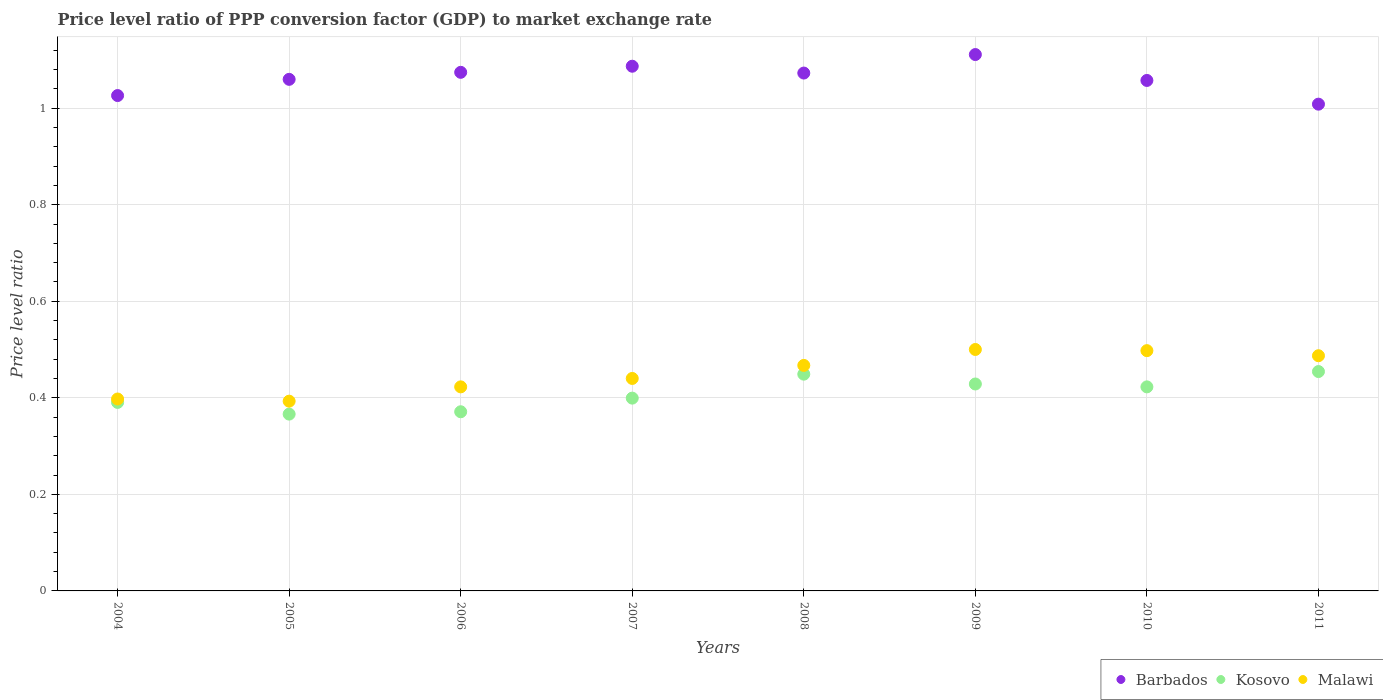How many different coloured dotlines are there?
Ensure brevity in your answer.  3. What is the price level ratio in Malawi in 2009?
Your answer should be very brief. 0.5. Across all years, what is the maximum price level ratio in Barbados?
Your response must be concise. 1.11. Across all years, what is the minimum price level ratio in Malawi?
Offer a very short reply. 0.39. In which year was the price level ratio in Malawi maximum?
Provide a succinct answer. 2009. In which year was the price level ratio in Barbados minimum?
Provide a short and direct response. 2011. What is the total price level ratio in Kosovo in the graph?
Offer a very short reply. 3.28. What is the difference between the price level ratio in Barbados in 2005 and that in 2011?
Make the answer very short. 0.05. What is the difference between the price level ratio in Malawi in 2008 and the price level ratio in Kosovo in 2009?
Your response must be concise. 0.04. What is the average price level ratio in Barbados per year?
Offer a very short reply. 1.06. In the year 2011, what is the difference between the price level ratio in Malawi and price level ratio in Kosovo?
Keep it short and to the point. 0.03. What is the ratio of the price level ratio in Kosovo in 2007 to that in 2011?
Make the answer very short. 0.88. What is the difference between the highest and the second highest price level ratio in Barbados?
Provide a succinct answer. 0.02. What is the difference between the highest and the lowest price level ratio in Malawi?
Your response must be concise. 0.11. Is the sum of the price level ratio in Malawi in 2005 and 2009 greater than the maximum price level ratio in Kosovo across all years?
Your response must be concise. Yes. Does the price level ratio in Barbados monotonically increase over the years?
Provide a succinct answer. No. Is the price level ratio in Malawi strictly greater than the price level ratio in Barbados over the years?
Make the answer very short. No. Is the price level ratio in Kosovo strictly less than the price level ratio in Barbados over the years?
Provide a short and direct response. Yes. How many dotlines are there?
Offer a very short reply. 3. How many years are there in the graph?
Provide a short and direct response. 8. Does the graph contain any zero values?
Keep it short and to the point. No. Does the graph contain grids?
Provide a short and direct response. Yes. Where does the legend appear in the graph?
Keep it short and to the point. Bottom right. How are the legend labels stacked?
Ensure brevity in your answer.  Horizontal. What is the title of the graph?
Provide a short and direct response. Price level ratio of PPP conversion factor (GDP) to market exchange rate. Does "Macedonia" appear as one of the legend labels in the graph?
Make the answer very short. No. What is the label or title of the Y-axis?
Provide a short and direct response. Price level ratio. What is the Price level ratio in Barbados in 2004?
Provide a succinct answer. 1.03. What is the Price level ratio of Kosovo in 2004?
Give a very brief answer. 0.39. What is the Price level ratio in Malawi in 2004?
Keep it short and to the point. 0.4. What is the Price level ratio of Barbados in 2005?
Offer a very short reply. 1.06. What is the Price level ratio of Kosovo in 2005?
Provide a succinct answer. 0.37. What is the Price level ratio of Malawi in 2005?
Your answer should be very brief. 0.39. What is the Price level ratio in Barbados in 2006?
Offer a terse response. 1.07. What is the Price level ratio in Kosovo in 2006?
Offer a very short reply. 0.37. What is the Price level ratio of Malawi in 2006?
Offer a very short reply. 0.42. What is the Price level ratio in Barbados in 2007?
Offer a very short reply. 1.09. What is the Price level ratio in Kosovo in 2007?
Make the answer very short. 0.4. What is the Price level ratio of Malawi in 2007?
Your response must be concise. 0.44. What is the Price level ratio in Barbados in 2008?
Offer a terse response. 1.07. What is the Price level ratio of Kosovo in 2008?
Offer a terse response. 0.45. What is the Price level ratio in Malawi in 2008?
Offer a very short reply. 0.47. What is the Price level ratio of Barbados in 2009?
Your answer should be very brief. 1.11. What is the Price level ratio in Kosovo in 2009?
Offer a very short reply. 0.43. What is the Price level ratio of Malawi in 2009?
Your response must be concise. 0.5. What is the Price level ratio of Barbados in 2010?
Provide a short and direct response. 1.06. What is the Price level ratio of Kosovo in 2010?
Your response must be concise. 0.42. What is the Price level ratio of Malawi in 2010?
Provide a short and direct response. 0.5. What is the Price level ratio of Barbados in 2011?
Provide a short and direct response. 1.01. What is the Price level ratio of Kosovo in 2011?
Ensure brevity in your answer.  0.45. What is the Price level ratio in Malawi in 2011?
Provide a short and direct response. 0.49. Across all years, what is the maximum Price level ratio in Barbados?
Provide a succinct answer. 1.11. Across all years, what is the maximum Price level ratio in Kosovo?
Ensure brevity in your answer.  0.45. Across all years, what is the maximum Price level ratio of Malawi?
Provide a succinct answer. 0.5. Across all years, what is the minimum Price level ratio of Barbados?
Offer a terse response. 1.01. Across all years, what is the minimum Price level ratio in Kosovo?
Offer a very short reply. 0.37. Across all years, what is the minimum Price level ratio in Malawi?
Make the answer very short. 0.39. What is the total Price level ratio in Barbados in the graph?
Make the answer very short. 8.5. What is the total Price level ratio in Kosovo in the graph?
Provide a short and direct response. 3.28. What is the total Price level ratio of Malawi in the graph?
Provide a short and direct response. 3.61. What is the difference between the Price level ratio of Barbados in 2004 and that in 2005?
Your answer should be compact. -0.03. What is the difference between the Price level ratio in Kosovo in 2004 and that in 2005?
Provide a short and direct response. 0.02. What is the difference between the Price level ratio of Malawi in 2004 and that in 2005?
Keep it short and to the point. 0. What is the difference between the Price level ratio of Barbados in 2004 and that in 2006?
Offer a very short reply. -0.05. What is the difference between the Price level ratio in Kosovo in 2004 and that in 2006?
Your answer should be very brief. 0.02. What is the difference between the Price level ratio of Malawi in 2004 and that in 2006?
Provide a short and direct response. -0.03. What is the difference between the Price level ratio of Barbados in 2004 and that in 2007?
Your answer should be very brief. -0.06. What is the difference between the Price level ratio of Kosovo in 2004 and that in 2007?
Provide a short and direct response. -0.01. What is the difference between the Price level ratio of Malawi in 2004 and that in 2007?
Offer a terse response. -0.04. What is the difference between the Price level ratio of Barbados in 2004 and that in 2008?
Ensure brevity in your answer.  -0.05. What is the difference between the Price level ratio in Kosovo in 2004 and that in 2008?
Your response must be concise. -0.06. What is the difference between the Price level ratio in Malawi in 2004 and that in 2008?
Keep it short and to the point. -0.07. What is the difference between the Price level ratio in Barbados in 2004 and that in 2009?
Your response must be concise. -0.08. What is the difference between the Price level ratio in Kosovo in 2004 and that in 2009?
Keep it short and to the point. -0.04. What is the difference between the Price level ratio in Malawi in 2004 and that in 2009?
Make the answer very short. -0.1. What is the difference between the Price level ratio of Barbados in 2004 and that in 2010?
Your answer should be very brief. -0.03. What is the difference between the Price level ratio in Kosovo in 2004 and that in 2010?
Your response must be concise. -0.03. What is the difference between the Price level ratio in Malawi in 2004 and that in 2010?
Provide a short and direct response. -0.1. What is the difference between the Price level ratio in Barbados in 2004 and that in 2011?
Your response must be concise. 0.02. What is the difference between the Price level ratio of Kosovo in 2004 and that in 2011?
Keep it short and to the point. -0.06. What is the difference between the Price level ratio in Malawi in 2004 and that in 2011?
Provide a short and direct response. -0.09. What is the difference between the Price level ratio of Barbados in 2005 and that in 2006?
Provide a short and direct response. -0.01. What is the difference between the Price level ratio in Kosovo in 2005 and that in 2006?
Make the answer very short. -0. What is the difference between the Price level ratio in Malawi in 2005 and that in 2006?
Offer a terse response. -0.03. What is the difference between the Price level ratio in Barbados in 2005 and that in 2007?
Give a very brief answer. -0.03. What is the difference between the Price level ratio in Kosovo in 2005 and that in 2007?
Make the answer very short. -0.03. What is the difference between the Price level ratio of Malawi in 2005 and that in 2007?
Make the answer very short. -0.05. What is the difference between the Price level ratio in Barbados in 2005 and that in 2008?
Your answer should be compact. -0.01. What is the difference between the Price level ratio in Kosovo in 2005 and that in 2008?
Give a very brief answer. -0.08. What is the difference between the Price level ratio of Malawi in 2005 and that in 2008?
Offer a terse response. -0.07. What is the difference between the Price level ratio of Barbados in 2005 and that in 2009?
Make the answer very short. -0.05. What is the difference between the Price level ratio of Kosovo in 2005 and that in 2009?
Give a very brief answer. -0.06. What is the difference between the Price level ratio of Malawi in 2005 and that in 2009?
Provide a succinct answer. -0.11. What is the difference between the Price level ratio in Barbados in 2005 and that in 2010?
Offer a terse response. 0. What is the difference between the Price level ratio in Kosovo in 2005 and that in 2010?
Offer a terse response. -0.06. What is the difference between the Price level ratio of Malawi in 2005 and that in 2010?
Your answer should be very brief. -0.1. What is the difference between the Price level ratio of Barbados in 2005 and that in 2011?
Provide a short and direct response. 0.05. What is the difference between the Price level ratio of Kosovo in 2005 and that in 2011?
Your answer should be very brief. -0.09. What is the difference between the Price level ratio in Malawi in 2005 and that in 2011?
Your answer should be very brief. -0.09. What is the difference between the Price level ratio of Barbados in 2006 and that in 2007?
Your response must be concise. -0.01. What is the difference between the Price level ratio in Kosovo in 2006 and that in 2007?
Make the answer very short. -0.03. What is the difference between the Price level ratio of Malawi in 2006 and that in 2007?
Make the answer very short. -0.02. What is the difference between the Price level ratio in Barbados in 2006 and that in 2008?
Provide a succinct answer. 0. What is the difference between the Price level ratio of Kosovo in 2006 and that in 2008?
Make the answer very short. -0.08. What is the difference between the Price level ratio of Malawi in 2006 and that in 2008?
Ensure brevity in your answer.  -0.04. What is the difference between the Price level ratio in Barbados in 2006 and that in 2009?
Your answer should be very brief. -0.04. What is the difference between the Price level ratio of Kosovo in 2006 and that in 2009?
Offer a terse response. -0.06. What is the difference between the Price level ratio of Malawi in 2006 and that in 2009?
Your answer should be compact. -0.08. What is the difference between the Price level ratio in Barbados in 2006 and that in 2010?
Offer a very short reply. 0.02. What is the difference between the Price level ratio in Kosovo in 2006 and that in 2010?
Your answer should be compact. -0.05. What is the difference between the Price level ratio in Malawi in 2006 and that in 2010?
Provide a short and direct response. -0.07. What is the difference between the Price level ratio of Barbados in 2006 and that in 2011?
Offer a very short reply. 0.07. What is the difference between the Price level ratio of Kosovo in 2006 and that in 2011?
Ensure brevity in your answer.  -0.08. What is the difference between the Price level ratio of Malawi in 2006 and that in 2011?
Offer a terse response. -0.06. What is the difference between the Price level ratio in Barbados in 2007 and that in 2008?
Give a very brief answer. 0.01. What is the difference between the Price level ratio of Kosovo in 2007 and that in 2008?
Make the answer very short. -0.05. What is the difference between the Price level ratio in Malawi in 2007 and that in 2008?
Ensure brevity in your answer.  -0.03. What is the difference between the Price level ratio of Barbados in 2007 and that in 2009?
Ensure brevity in your answer.  -0.02. What is the difference between the Price level ratio in Kosovo in 2007 and that in 2009?
Your response must be concise. -0.03. What is the difference between the Price level ratio in Malawi in 2007 and that in 2009?
Offer a terse response. -0.06. What is the difference between the Price level ratio of Barbados in 2007 and that in 2010?
Offer a terse response. 0.03. What is the difference between the Price level ratio of Kosovo in 2007 and that in 2010?
Your response must be concise. -0.02. What is the difference between the Price level ratio of Malawi in 2007 and that in 2010?
Provide a succinct answer. -0.06. What is the difference between the Price level ratio of Barbados in 2007 and that in 2011?
Your answer should be compact. 0.08. What is the difference between the Price level ratio of Kosovo in 2007 and that in 2011?
Ensure brevity in your answer.  -0.06. What is the difference between the Price level ratio of Malawi in 2007 and that in 2011?
Your answer should be compact. -0.05. What is the difference between the Price level ratio in Barbados in 2008 and that in 2009?
Offer a terse response. -0.04. What is the difference between the Price level ratio in Kosovo in 2008 and that in 2009?
Keep it short and to the point. 0.02. What is the difference between the Price level ratio of Malawi in 2008 and that in 2009?
Provide a short and direct response. -0.03. What is the difference between the Price level ratio of Barbados in 2008 and that in 2010?
Give a very brief answer. 0.02. What is the difference between the Price level ratio in Kosovo in 2008 and that in 2010?
Your answer should be very brief. 0.03. What is the difference between the Price level ratio in Malawi in 2008 and that in 2010?
Give a very brief answer. -0.03. What is the difference between the Price level ratio of Barbados in 2008 and that in 2011?
Make the answer very short. 0.06. What is the difference between the Price level ratio of Kosovo in 2008 and that in 2011?
Make the answer very short. -0.01. What is the difference between the Price level ratio of Malawi in 2008 and that in 2011?
Your response must be concise. -0.02. What is the difference between the Price level ratio in Barbados in 2009 and that in 2010?
Offer a very short reply. 0.05. What is the difference between the Price level ratio of Kosovo in 2009 and that in 2010?
Ensure brevity in your answer.  0.01. What is the difference between the Price level ratio of Malawi in 2009 and that in 2010?
Give a very brief answer. 0. What is the difference between the Price level ratio of Barbados in 2009 and that in 2011?
Make the answer very short. 0.1. What is the difference between the Price level ratio of Kosovo in 2009 and that in 2011?
Provide a succinct answer. -0.03. What is the difference between the Price level ratio of Malawi in 2009 and that in 2011?
Give a very brief answer. 0.01. What is the difference between the Price level ratio of Barbados in 2010 and that in 2011?
Offer a terse response. 0.05. What is the difference between the Price level ratio in Kosovo in 2010 and that in 2011?
Your answer should be compact. -0.03. What is the difference between the Price level ratio of Malawi in 2010 and that in 2011?
Offer a very short reply. 0.01. What is the difference between the Price level ratio of Barbados in 2004 and the Price level ratio of Kosovo in 2005?
Provide a short and direct response. 0.66. What is the difference between the Price level ratio in Barbados in 2004 and the Price level ratio in Malawi in 2005?
Provide a succinct answer. 0.63. What is the difference between the Price level ratio of Kosovo in 2004 and the Price level ratio of Malawi in 2005?
Make the answer very short. -0. What is the difference between the Price level ratio in Barbados in 2004 and the Price level ratio in Kosovo in 2006?
Make the answer very short. 0.66. What is the difference between the Price level ratio in Barbados in 2004 and the Price level ratio in Malawi in 2006?
Your answer should be compact. 0.6. What is the difference between the Price level ratio of Kosovo in 2004 and the Price level ratio of Malawi in 2006?
Offer a very short reply. -0.03. What is the difference between the Price level ratio in Barbados in 2004 and the Price level ratio in Kosovo in 2007?
Offer a terse response. 0.63. What is the difference between the Price level ratio of Barbados in 2004 and the Price level ratio of Malawi in 2007?
Your response must be concise. 0.59. What is the difference between the Price level ratio of Kosovo in 2004 and the Price level ratio of Malawi in 2007?
Provide a succinct answer. -0.05. What is the difference between the Price level ratio of Barbados in 2004 and the Price level ratio of Kosovo in 2008?
Your response must be concise. 0.58. What is the difference between the Price level ratio of Barbados in 2004 and the Price level ratio of Malawi in 2008?
Keep it short and to the point. 0.56. What is the difference between the Price level ratio in Kosovo in 2004 and the Price level ratio in Malawi in 2008?
Provide a short and direct response. -0.08. What is the difference between the Price level ratio of Barbados in 2004 and the Price level ratio of Kosovo in 2009?
Provide a short and direct response. 0.6. What is the difference between the Price level ratio of Barbados in 2004 and the Price level ratio of Malawi in 2009?
Provide a succinct answer. 0.53. What is the difference between the Price level ratio of Kosovo in 2004 and the Price level ratio of Malawi in 2009?
Make the answer very short. -0.11. What is the difference between the Price level ratio of Barbados in 2004 and the Price level ratio of Kosovo in 2010?
Make the answer very short. 0.6. What is the difference between the Price level ratio of Barbados in 2004 and the Price level ratio of Malawi in 2010?
Give a very brief answer. 0.53. What is the difference between the Price level ratio in Kosovo in 2004 and the Price level ratio in Malawi in 2010?
Keep it short and to the point. -0.11. What is the difference between the Price level ratio of Barbados in 2004 and the Price level ratio of Kosovo in 2011?
Make the answer very short. 0.57. What is the difference between the Price level ratio in Barbados in 2004 and the Price level ratio in Malawi in 2011?
Your answer should be very brief. 0.54. What is the difference between the Price level ratio of Kosovo in 2004 and the Price level ratio of Malawi in 2011?
Keep it short and to the point. -0.1. What is the difference between the Price level ratio in Barbados in 2005 and the Price level ratio in Kosovo in 2006?
Ensure brevity in your answer.  0.69. What is the difference between the Price level ratio in Barbados in 2005 and the Price level ratio in Malawi in 2006?
Keep it short and to the point. 0.64. What is the difference between the Price level ratio in Kosovo in 2005 and the Price level ratio in Malawi in 2006?
Your response must be concise. -0.06. What is the difference between the Price level ratio of Barbados in 2005 and the Price level ratio of Kosovo in 2007?
Offer a terse response. 0.66. What is the difference between the Price level ratio in Barbados in 2005 and the Price level ratio in Malawi in 2007?
Make the answer very short. 0.62. What is the difference between the Price level ratio in Kosovo in 2005 and the Price level ratio in Malawi in 2007?
Offer a terse response. -0.07. What is the difference between the Price level ratio in Barbados in 2005 and the Price level ratio in Kosovo in 2008?
Give a very brief answer. 0.61. What is the difference between the Price level ratio in Barbados in 2005 and the Price level ratio in Malawi in 2008?
Your answer should be very brief. 0.59. What is the difference between the Price level ratio of Kosovo in 2005 and the Price level ratio of Malawi in 2008?
Provide a succinct answer. -0.1. What is the difference between the Price level ratio in Barbados in 2005 and the Price level ratio in Kosovo in 2009?
Make the answer very short. 0.63. What is the difference between the Price level ratio of Barbados in 2005 and the Price level ratio of Malawi in 2009?
Offer a very short reply. 0.56. What is the difference between the Price level ratio of Kosovo in 2005 and the Price level ratio of Malawi in 2009?
Ensure brevity in your answer.  -0.13. What is the difference between the Price level ratio of Barbados in 2005 and the Price level ratio of Kosovo in 2010?
Provide a short and direct response. 0.64. What is the difference between the Price level ratio in Barbados in 2005 and the Price level ratio in Malawi in 2010?
Keep it short and to the point. 0.56. What is the difference between the Price level ratio of Kosovo in 2005 and the Price level ratio of Malawi in 2010?
Offer a terse response. -0.13. What is the difference between the Price level ratio of Barbados in 2005 and the Price level ratio of Kosovo in 2011?
Offer a very short reply. 0.61. What is the difference between the Price level ratio of Barbados in 2005 and the Price level ratio of Malawi in 2011?
Your response must be concise. 0.57. What is the difference between the Price level ratio of Kosovo in 2005 and the Price level ratio of Malawi in 2011?
Your response must be concise. -0.12. What is the difference between the Price level ratio in Barbados in 2006 and the Price level ratio in Kosovo in 2007?
Ensure brevity in your answer.  0.67. What is the difference between the Price level ratio of Barbados in 2006 and the Price level ratio of Malawi in 2007?
Provide a short and direct response. 0.63. What is the difference between the Price level ratio in Kosovo in 2006 and the Price level ratio in Malawi in 2007?
Offer a terse response. -0.07. What is the difference between the Price level ratio of Barbados in 2006 and the Price level ratio of Kosovo in 2008?
Offer a terse response. 0.63. What is the difference between the Price level ratio of Barbados in 2006 and the Price level ratio of Malawi in 2008?
Ensure brevity in your answer.  0.61. What is the difference between the Price level ratio of Kosovo in 2006 and the Price level ratio of Malawi in 2008?
Give a very brief answer. -0.1. What is the difference between the Price level ratio in Barbados in 2006 and the Price level ratio in Kosovo in 2009?
Provide a short and direct response. 0.65. What is the difference between the Price level ratio in Barbados in 2006 and the Price level ratio in Malawi in 2009?
Your answer should be compact. 0.57. What is the difference between the Price level ratio of Kosovo in 2006 and the Price level ratio of Malawi in 2009?
Keep it short and to the point. -0.13. What is the difference between the Price level ratio in Barbados in 2006 and the Price level ratio in Kosovo in 2010?
Ensure brevity in your answer.  0.65. What is the difference between the Price level ratio in Barbados in 2006 and the Price level ratio in Malawi in 2010?
Your response must be concise. 0.58. What is the difference between the Price level ratio of Kosovo in 2006 and the Price level ratio of Malawi in 2010?
Make the answer very short. -0.13. What is the difference between the Price level ratio of Barbados in 2006 and the Price level ratio of Kosovo in 2011?
Offer a terse response. 0.62. What is the difference between the Price level ratio in Barbados in 2006 and the Price level ratio in Malawi in 2011?
Offer a terse response. 0.59. What is the difference between the Price level ratio in Kosovo in 2006 and the Price level ratio in Malawi in 2011?
Give a very brief answer. -0.12. What is the difference between the Price level ratio of Barbados in 2007 and the Price level ratio of Kosovo in 2008?
Your answer should be very brief. 0.64. What is the difference between the Price level ratio of Barbados in 2007 and the Price level ratio of Malawi in 2008?
Ensure brevity in your answer.  0.62. What is the difference between the Price level ratio in Kosovo in 2007 and the Price level ratio in Malawi in 2008?
Offer a very short reply. -0.07. What is the difference between the Price level ratio in Barbados in 2007 and the Price level ratio in Kosovo in 2009?
Give a very brief answer. 0.66. What is the difference between the Price level ratio in Barbados in 2007 and the Price level ratio in Malawi in 2009?
Ensure brevity in your answer.  0.59. What is the difference between the Price level ratio of Kosovo in 2007 and the Price level ratio of Malawi in 2009?
Your answer should be very brief. -0.1. What is the difference between the Price level ratio of Barbados in 2007 and the Price level ratio of Kosovo in 2010?
Your response must be concise. 0.66. What is the difference between the Price level ratio of Barbados in 2007 and the Price level ratio of Malawi in 2010?
Provide a short and direct response. 0.59. What is the difference between the Price level ratio of Kosovo in 2007 and the Price level ratio of Malawi in 2010?
Offer a very short reply. -0.1. What is the difference between the Price level ratio of Barbados in 2007 and the Price level ratio of Kosovo in 2011?
Make the answer very short. 0.63. What is the difference between the Price level ratio in Barbados in 2007 and the Price level ratio in Malawi in 2011?
Provide a short and direct response. 0.6. What is the difference between the Price level ratio in Kosovo in 2007 and the Price level ratio in Malawi in 2011?
Ensure brevity in your answer.  -0.09. What is the difference between the Price level ratio in Barbados in 2008 and the Price level ratio in Kosovo in 2009?
Your answer should be compact. 0.64. What is the difference between the Price level ratio of Barbados in 2008 and the Price level ratio of Malawi in 2009?
Your answer should be compact. 0.57. What is the difference between the Price level ratio of Kosovo in 2008 and the Price level ratio of Malawi in 2009?
Your response must be concise. -0.05. What is the difference between the Price level ratio in Barbados in 2008 and the Price level ratio in Kosovo in 2010?
Your response must be concise. 0.65. What is the difference between the Price level ratio in Barbados in 2008 and the Price level ratio in Malawi in 2010?
Give a very brief answer. 0.58. What is the difference between the Price level ratio in Kosovo in 2008 and the Price level ratio in Malawi in 2010?
Offer a terse response. -0.05. What is the difference between the Price level ratio of Barbados in 2008 and the Price level ratio of Kosovo in 2011?
Ensure brevity in your answer.  0.62. What is the difference between the Price level ratio in Barbados in 2008 and the Price level ratio in Malawi in 2011?
Ensure brevity in your answer.  0.59. What is the difference between the Price level ratio in Kosovo in 2008 and the Price level ratio in Malawi in 2011?
Your answer should be very brief. -0.04. What is the difference between the Price level ratio in Barbados in 2009 and the Price level ratio in Kosovo in 2010?
Make the answer very short. 0.69. What is the difference between the Price level ratio in Barbados in 2009 and the Price level ratio in Malawi in 2010?
Your answer should be very brief. 0.61. What is the difference between the Price level ratio in Kosovo in 2009 and the Price level ratio in Malawi in 2010?
Offer a very short reply. -0.07. What is the difference between the Price level ratio in Barbados in 2009 and the Price level ratio in Kosovo in 2011?
Keep it short and to the point. 0.66. What is the difference between the Price level ratio of Barbados in 2009 and the Price level ratio of Malawi in 2011?
Make the answer very short. 0.62. What is the difference between the Price level ratio of Kosovo in 2009 and the Price level ratio of Malawi in 2011?
Your response must be concise. -0.06. What is the difference between the Price level ratio of Barbados in 2010 and the Price level ratio of Kosovo in 2011?
Ensure brevity in your answer.  0.6. What is the difference between the Price level ratio in Barbados in 2010 and the Price level ratio in Malawi in 2011?
Provide a succinct answer. 0.57. What is the difference between the Price level ratio of Kosovo in 2010 and the Price level ratio of Malawi in 2011?
Offer a very short reply. -0.06. What is the average Price level ratio in Barbados per year?
Your answer should be compact. 1.06. What is the average Price level ratio in Kosovo per year?
Your answer should be compact. 0.41. What is the average Price level ratio of Malawi per year?
Your answer should be very brief. 0.45. In the year 2004, what is the difference between the Price level ratio in Barbados and Price level ratio in Kosovo?
Provide a short and direct response. 0.64. In the year 2004, what is the difference between the Price level ratio of Barbados and Price level ratio of Malawi?
Provide a succinct answer. 0.63. In the year 2004, what is the difference between the Price level ratio in Kosovo and Price level ratio in Malawi?
Your answer should be compact. -0.01. In the year 2005, what is the difference between the Price level ratio in Barbados and Price level ratio in Kosovo?
Your response must be concise. 0.69. In the year 2005, what is the difference between the Price level ratio of Kosovo and Price level ratio of Malawi?
Offer a terse response. -0.03. In the year 2006, what is the difference between the Price level ratio of Barbados and Price level ratio of Kosovo?
Your answer should be very brief. 0.7. In the year 2006, what is the difference between the Price level ratio in Barbados and Price level ratio in Malawi?
Make the answer very short. 0.65. In the year 2006, what is the difference between the Price level ratio of Kosovo and Price level ratio of Malawi?
Give a very brief answer. -0.05. In the year 2007, what is the difference between the Price level ratio in Barbados and Price level ratio in Kosovo?
Your answer should be compact. 0.69. In the year 2007, what is the difference between the Price level ratio of Barbados and Price level ratio of Malawi?
Your answer should be very brief. 0.65. In the year 2007, what is the difference between the Price level ratio in Kosovo and Price level ratio in Malawi?
Offer a very short reply. -0.04. In the year 2008, what is the difference between the Price level ratio of Barbados and Price level ratio of Kosovo?
Provide a succinct answer. 0.62. In the year 2008, what is the difference between the Price level ratio of Barbados and Price level ratio of Malawi?
Ensure brevity in your answer.  0.61. In the year 2008, what is the difference between the Price level ratio in Kosovo and Price level ratio in Malawi?
Provide a succinct answer. -0.02. In the year 2009, what is the difference between the Price level ratio in Barbados and Price level ratio in Kosovo?
Provide a succinct answer. 0.68. In the year 2009, what is the difference between the Price level ratio of Barbados and Price level ratio of Malawi?
Give a very brief answer. 0.61. In the year 2009, what is the difference between the Price level ratio of Kosovo and Price level ratio of Malawi?
Your response must be concise. -0.07. In the year 2010, what is the difference between the Price level ratio of Barbados and Price level ratio of Kosovo?
Make the answer very short. 0.63. In the year 2010, what is the difference between the Price level ratio in Barbados and Price level ratio in Malawi?
Give a very brief answer. 0.56. In the year 2010, what is the difference between the Price level ratio of Kosovo and Price level ratio of Malawi?
Your response must be concise. -0.07. In the year 2011, what is the difference between the Price level ratio of Barbados and Price level ratio of Kosovo?
Make the answer very short. 0.55. In the year 2011, what is the difference between the Price level ratio in Barbados and Price level ratio in Malawi?
Your response must be concise. 0.52. In the year 2011, what is the difference between the Price level ratio in Kosovo and Price level ratio in Malawi?
Provide a short and direct response. -0.03. What is the ratio of the Price level ratio in Barbados in 2004 to that in 2005?
Give a very brief answer. 0.97. What is the ratio of the Price level ratio of Kosovo in 2004 to that in 2005?
Provide a succinct answer. 1.07. What is the ratio of the Price level ratio in Malawi in 2004 to that in 2005?
Provide a succinct answer. 1.01. What is the ratio of the Price level ratio of Barbados in 2004 to that in 2006?
Offer a terse response. 0.96. What is the ratio of the Price level ratio of Kosovo in 2004 to that in 2006?
Your answer should be very brief. 1.05. What is the ratio of the Price level ratio in Malawi in 2004 to that in 2006?
Provide a short and direct response. 0.94. What is the ratio of the Price level ratio in Barbados in 2004 to that in 2007?
Your answer should be very brief. 0.94. What is the ratio of the Price level ratio in Kosovo in 2004 to that in 2007?
Offer a very short reply. 0.98. What is the ratio of the Price level ratio of Malawi in 2004 to that in 2007?
Your answer should be compact. 0.9. What is the ratio of the Price level ratio in Barbados in 2004 to that in 2008?
Offer a very short reply. 0.96. What is the ratio of the Price level ratio in Kosovo in 2004 to that in 2008?
Offer a very short reply. 0.87. What is the ratio of the Price level ratio in Malawi in 2004 to that in 2008?
Give a very brief answer. 0.85. What is the ratio of the Price level ratio of Barbados in 2004 to that in 2009?
Give a very brief answer. 0.92. What is the ratio of the Price level ratio of Kosovo in 2004 to that in 2009?
Your answer should be very brief. 0.91. What is the ratio of the Price level ratio of Malawi in 2004 to that in 2009?
Your answer should be compact. 0.79. What is the ratio of the Price level ratio of Barbados in 2004 to that in 2010?
Keep it short and to the point. 0.97. What is the ratio of the Price level ratio of Kosovo in 2004 to that in 2010?
Offer a very short reply. 0.92. What is the ratio of the Price level ratio in Malawi in 2004 to that in 2010?
Your answer should be compact. 0.8. What is the ratio of the Price level ratio in Barbados in 2004 to that in 2011?
Your answer should be very brief. 1.02. What is the ratio of the Price level ratio in Kosovo in 2004 to that in 2011?
Your answer should be very brief. 0.86. What is the ratio of the Price level ratio in Malawi in 2004 to that in 2011?
Keep it short and to the point. 0.82. What is the ratio of the Price level ratio in Barbados in 2005 to that in 2006?
Keep it short and to the point. 0.99. What is the ratio of the Price level ratio of Kosovo in 2005 to that in 2006?
Offer a very short reply. 0.99. What is the ratio of the Price level ratio of Malawi in 2005 to that in 2006?
Your answer should be very brief. 0.93. What is the ratio of the Price level ratio in Kosovo in 2005 to that in 2007?
Your answer should be compact. 0.92. What is the ratio of the Price level ratio in Malawi in 2005 to that in 2007?
Provide a short and direct response. 0.89. What is the ratio of the Price level ratio in Barbados in 2005 to that in 2008?
Provide a short and direct response. 0.99. What is the ratio of the Price level ratio in Kosovo in 2005 to that in 2008?
Provide a succinct answer. 0.82. What is the ratio of the Price level ratio in Malawi in 2005 to that in 2008?
Provide a short and direct response. 0.84. What is the ratio of the Price level ratio in Barbados in 2005 to that in 2009?
Offer a very short reply. 0.95. What is the ratio of the Price level ratio in Kosovo in 2005 to that in 2009?
Offer a very short reply. 0.85. What is the ratio of the Price level ratio of Malawi in 2005 to that in 2009?
Make the answer very short. 0.79. What is the ratio of the Price level ratio of Kosovo in 2005 to that in 2010?
Make the answer very short. 0.87. What is the ratio of the Price level ratio of Malawi in 2005 to that in 2010?
Keep it short and to the point. 0.79. What is the ratio of the Price level ratio of Barbados in 2005 to that in 2011?
Provide a succinct answer. 1.05. What is the ratio of the Price level ratio of Kosovo in 2005 to that in 2011?
Your response must be concise. 0.81. What is the ratio of the Price level ratio in Malawi in 2005 to that in 2011?
Keep it short and to the point. 0.81. What is the ratio of the Price level ratio of Barbados in 2006 to that in 2007?
Give a very brief answer. 0.99. What is the ratio of the Price level ratio of Kosovo in 2006 to that in 2007?
Offer a very short reply. 0.93. What is the ratio of the Price level ratio in Malawi in 2006 to that in 2007?
Keep it short and to the point. 0.96. What is the ratio of the Price level ratio in Barbados in 2006 to that in 2008?
Provide a short and direct response. 1. What is the ratio of the Price level ratio in Kosovo in 2006 to that in 2008?
Offer a terse response. 0.83. What is the ratio of the Price level ratio in Malawi in 2006 to that in 2008?
Your answer should be compact. 0.9. What is the ratio of the Price level ratio of Barbados in 2006 to that in 2009?
Offer a very short reply. 0.97. What is the ratio of the Price level ratio in Kosovo in 2006 to that in 2009?
Offer a terse response. 0.87. What is the ratio of the Price level ratio of Malawi in 2006 to that in 2009?
Keep it short and to the point. 0.85. What is the ratio of the Price level ratio in Barbados in 2006 to that in 2010?
Keep it short and to the point. 1.02. What is the ratio of the Price level ratio of Kosovo in 2006 to that in 2010?
Offer a terse response. 0.88. What is the ratio of the Price level ratio of Malawi in 2006 to that in 2010?
Your response must be concise. 0.85. What is the ratio of the Price level ratio of Barbados in 2006 to that in 2011?
Offer a terse response. 1.07. What is the ratio of the Price level ratio in Kosovo in 2006 to that in 2011?
Give a very brief answer. 0.82. What is the ratio of the Price level ratio of Malawi in 2006 to that in 2011?
Offer a terse response. 0.87. What is the ratio of the Price level ratio in Barbados in 2007 to that in 2008?
Keep it short and to the point. 1.01. What is the ratio of the Price level ratio of Kosovo in 2007 to that in 2008?
Your response must be concise. 0.89. What is the ratio of the Price level ratio of Malawi in 2007 to that in 2008?
Your response must be concise. 0.94. What is the ratio of the Price level ratio of Barbados in 2007 to that in 2009?
Provide a short and direct response. 0.98. What is the ratio of the Price level ratio in Kosovo in 2007 to that in 2009?
Keep it short and to the point. 0.93. What is the ratio of the Price level ratio in Barbados in 2007 to that in 2010?
Ensure brevity in your answer.  1.03. What is the ratio of the Price level ratio in Kosovo in 2007 to that in 2010?
Give a very brief answer. 0.94. What is the ratio of the Price level ratio in Malawi in 2007 to that in 2010?
Make the answer very short. 0.88. What is the ratio of the Price level ratio of Barbados in 2007 to that in 2011?
Your response must be concise. 1.08. What is the ratio of the Price level ratio of Kosovo in 2007 to that in 2011?
Provide a succinct answer. 0.88. What is the ratio of the Price level ratio in Malawi in 2007 to that in 2011?
Provide a succinct answer. 0.9. What is the ratio of the Price level ratio in Barbados in 2008 to that in 2009?
Keep it short and to the point. 0.97. What is the ratio of the Price level ratio in Kosovo in 2008 to that in 2009?
Your answer should be very brief. 1.05. What is the ratio of the Price level ratio of Malawi in 2008 to that in 2009?
Your answer should be very brief. 0.93. What is the ratio of the Price level ratio of Barbados in 2008 to that in 2010?
Offer a terse response. 1.01. What is the ratio of the Price level ratio in Kosovo in 2008 to that in 2010?
Keep it short and to the point. 1.06. What is the ratio of the Price level ratio in Malawi in 2008 to that in 2010?
Provide a short and direct response. 0.94. What is the ratio of the Price level ratio of Barbados in 2008 to that in 2011?
Provide a succinct answer. 1.06. What is the ratio of the Price level ratio in Kosovo in 2008 to that in 2011?
Offer a very short reply. 0.99. What is the ratio of the Price level ratio of Malawi in 2008 to that in 2011?
Your answer should be compact. 0.96. What is the ratio of the Price level ratio of Barbados in 2009 to that in 2010?
Your answer should be very brief. 1.05. What is the ratio of the Price level ratio in Kosovo in 2009 to that in 2010?
Keep it short and to the point. 1.01. What is the ratio of the Price level ratio of Malawi in 2009 to that in 2010?
Your answer should be very brief. 1. What is the ratio of the Price level ratio in Barbados in 2009 to that in 2011?
Your response must be concise. 1.1. What is the ratio of the Price level ratio of Kosovo in 2009 to that in 2011?
Your response must be concise. 0.94. What is the ratio of the Price level ratio in Malawi in 2009 to that in 2011?
Ensure brevity in your answer.  1.03. What is the ratio of the Price level ratio in Barbados in 2010 to that in 2011?
Give a very brief answer. 1.05. What is the ratio of the Price level ratio of Kosovo in 2010 to that in 2011?
Ensure brevity in your answer.  0.93. What is the ratio of the Price level ratio of Malawi in 2010 to that in 2011?
Give a very brief answer. 1.02. What is the difference between the highest and the second highest Price level ratio in Barbados?
Your answer should be very brief. 0.02. What is the difference between the highest and the second highest Price level ratio in Kosovo?
Keep it short and to the point. 0.01. What is the difference between the highest and the second highest Price level ratio in Malawi?
Your response must be concise. 0. What is the difference between the highest and the lowest Price level ratio in Barbados?
Provide a succinct answer. 0.1. What is the difference between the highest and the lowest Price level ratio in Kosovo?
Give a very brief answer. 0.09. What is the difference between the highest and the lowest Price level ratio of Malawi?
Provide a short and direct response. 0.11. 